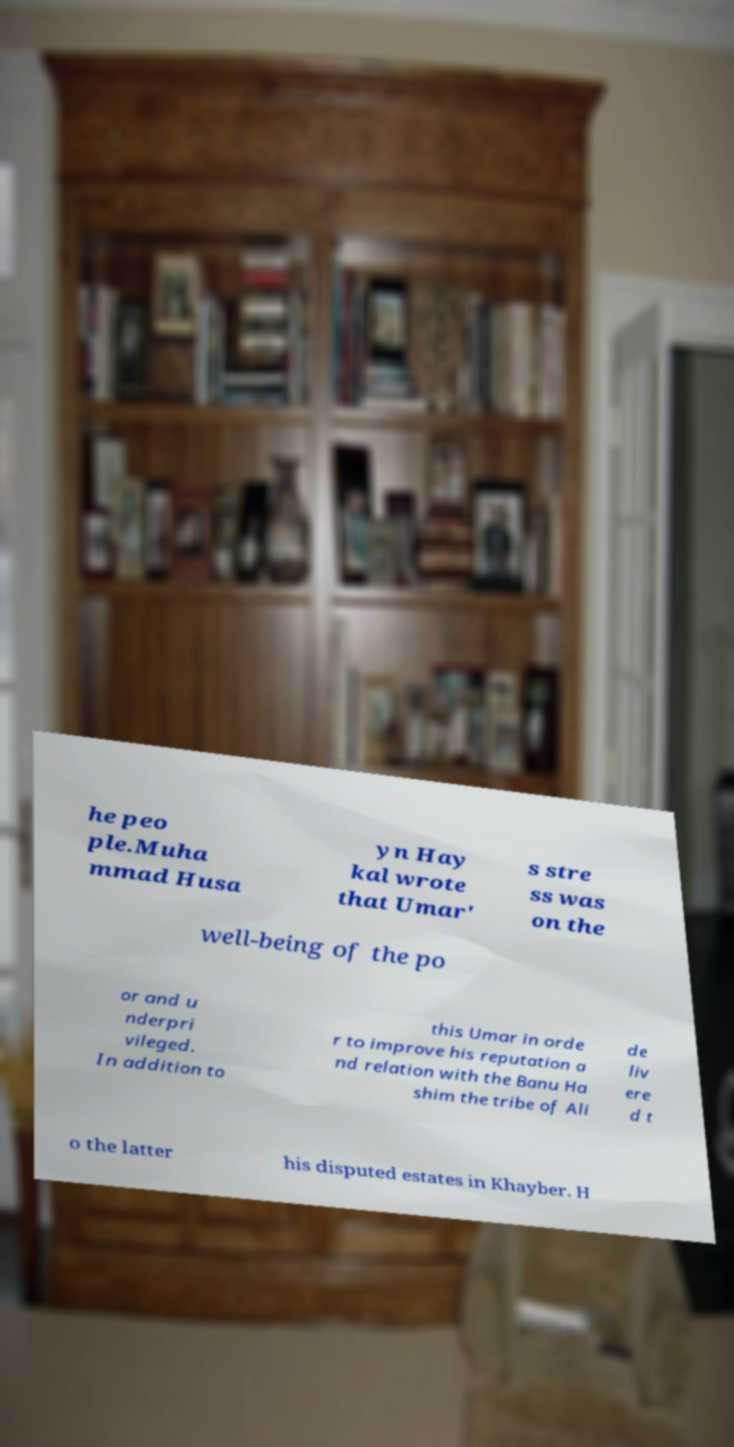There's text embedded in this image that I need extracted. Can you transcribe it verbatim? he peo ple.Muha mmad Husa yn Hay kal wrote that Umar' s stre ss was on the well-being of the po or and u nderpri vileged. In addition to this Umar in orde r to improve his reputation a nd relation with the Banu Ha shim the tribe of Ali de liv ere d t o the latter his disputed estates in Khayber. H 